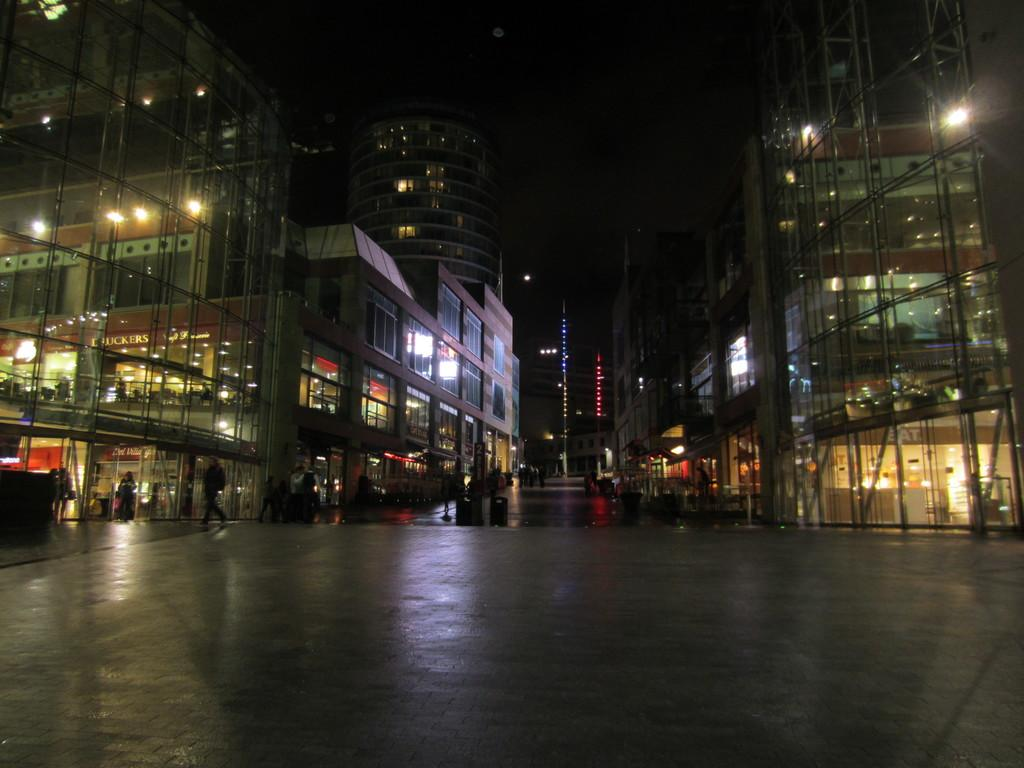What type of structures can be seen in the image? There are buildings in the image. What else is visible in the image besides the buildings? There are lights, glasses, people, and a road in the image. Can you describe the lighting conditions in the image? The background of the image is dark. What type of metal is the hand holding in the image? There is no hand holding any metal in the image. What is the zinc content of the glasses in the image? There is no information about the zinc content of the glasses in the image, as it does not mention any specific materials. 